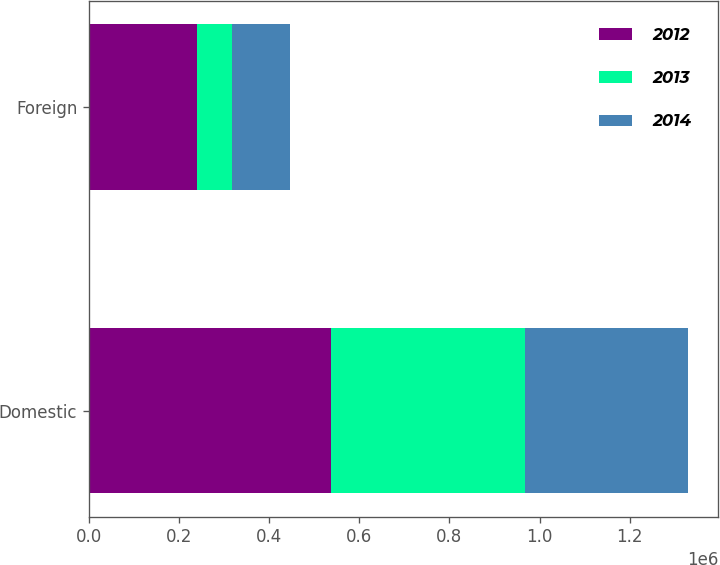Convert chart. <chart><loc_0><loc_0><loc_500><loc_500><stacked_bar_chart><ecel><fcel>Domestic<fcel>Foreign<nl><fcel>2012<fcel>537271<fcel>239991<nl><fcel>2013<fcel>431024<fcel>77961<nl><fcel>2014<fcel>361577<fcel>127901<nl></chart> 